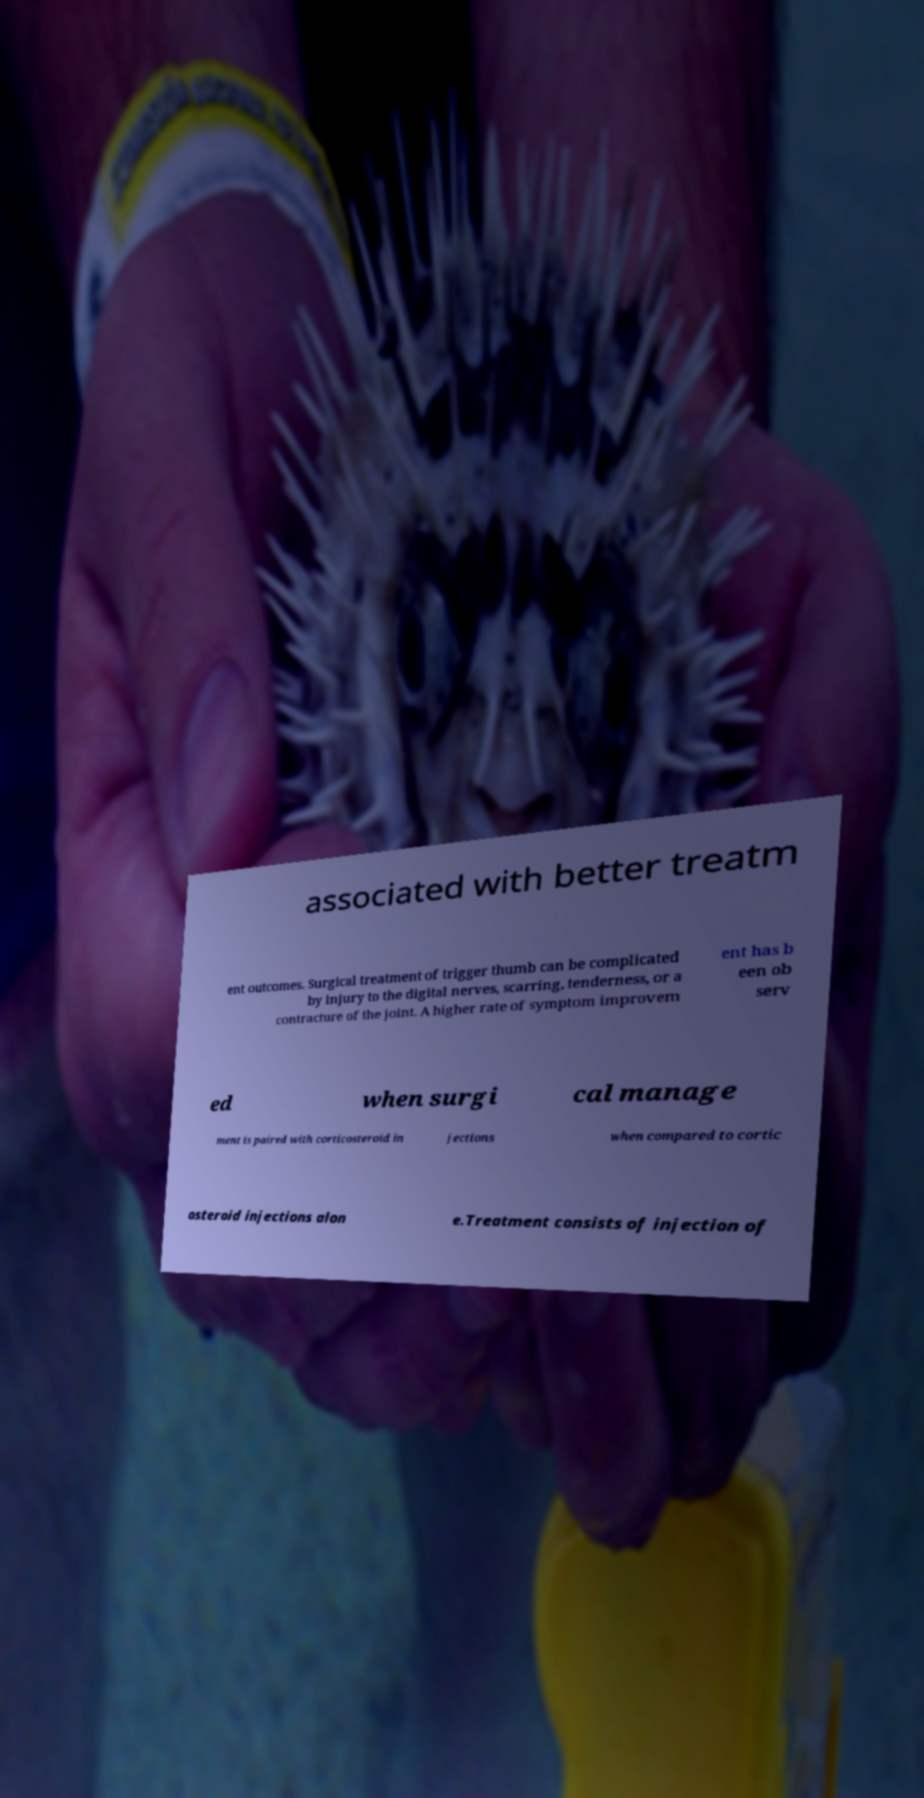Could you extract and type out the text from this image? associated with better treatm ent outcomes. Surgical treatment of trigger thumb can be complicated by injury to the digital nerves, scarring, tenderness, or a contracture of the joint. A higher rate of symptom improvem ent has b een ob serv ed when surgi cal manage ment is paired with corticosteroid in jections when compared to cortic osteroid injections alon e.Treatment consists of injection of 